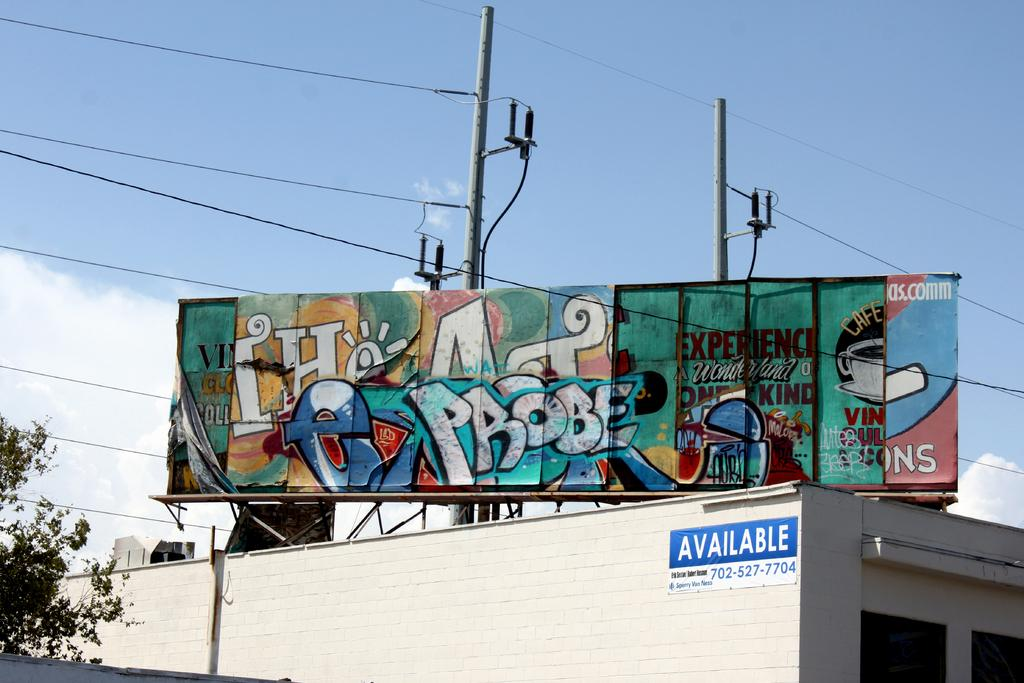<image>
Summarize the visual content of the image. A graffiti covered billboard eith the word Probe in the middle. 